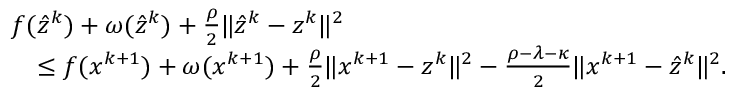Convert formula to latex. <formula><loc_0><loc_0><loc_500><loc_500>\begin{array} { r l } & { f ( \hat { z } ^ { k } ) + \omega ( \hat { z } ^ { k } ) + \frac { \rho } { 2 } \| \hat { z } ^ { k } - z ^ { k } \| ^ { 2 } } \\ & { \quad \leq f ( x ^ { k + 1 } ) + \omega ( x ^ { k + 1 } ) + \frac { \rho } { 2 } \| x ^ { k + 1 } - z ^ { k } \| ^ { 2 } - \frac { \rho - \lambda - \kappa } { 2 } \| x ^ { k + 1 } - \hat { z } ^ { k } \| ^ { 2 } . } \end{array}</formula> 